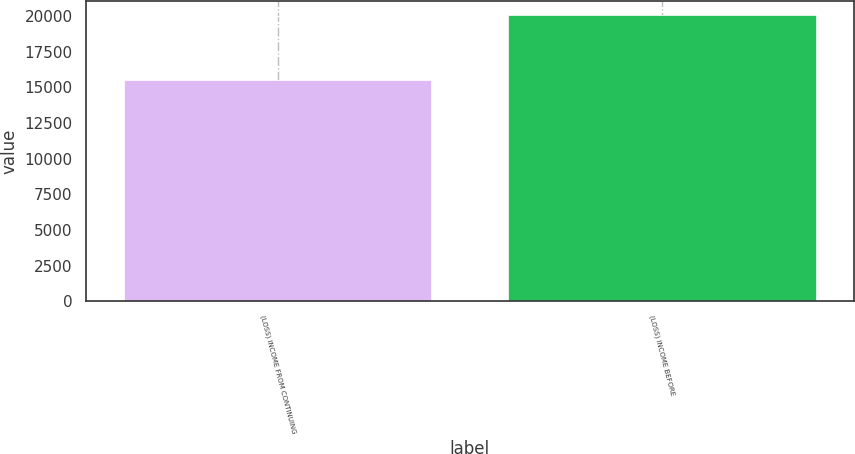<chart> <loc_0><loc_0><loc_500><loc_500><bar_chart><fcel>(LOSS) INCOME FROM CONTINUING<fcel>(LOSS) INCOME BEFORE<nl><fcel>15538<fcel>20044<nl></chart> 